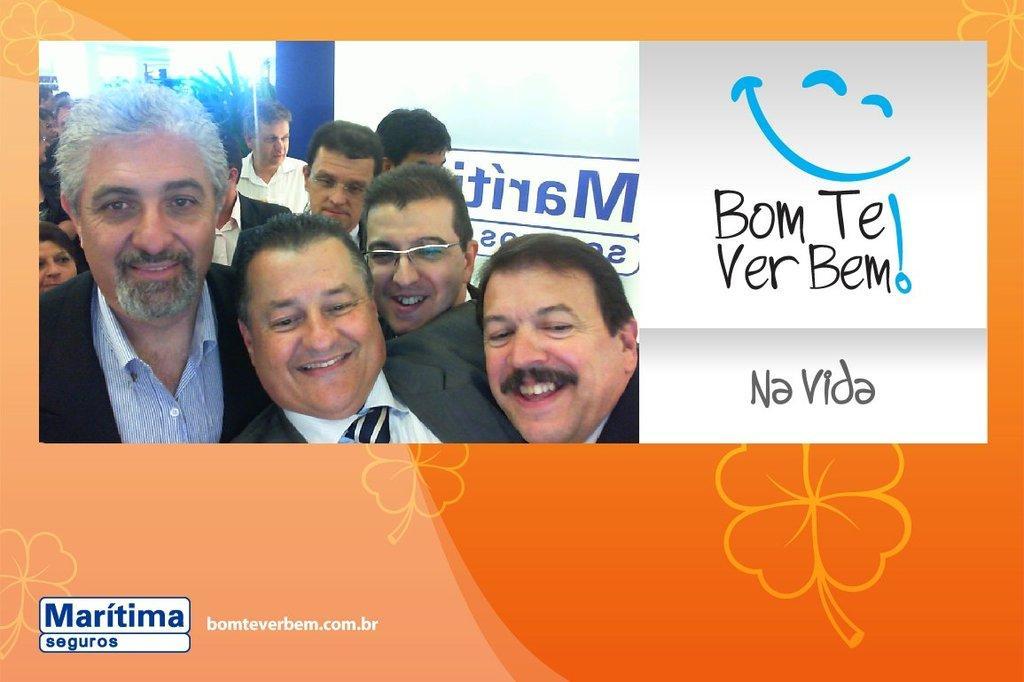How would you summarize this image in a sentence or two? In this picture I can see there is a poster and there is an image of few men standing and they are wearing blazers and there is something written on it. 